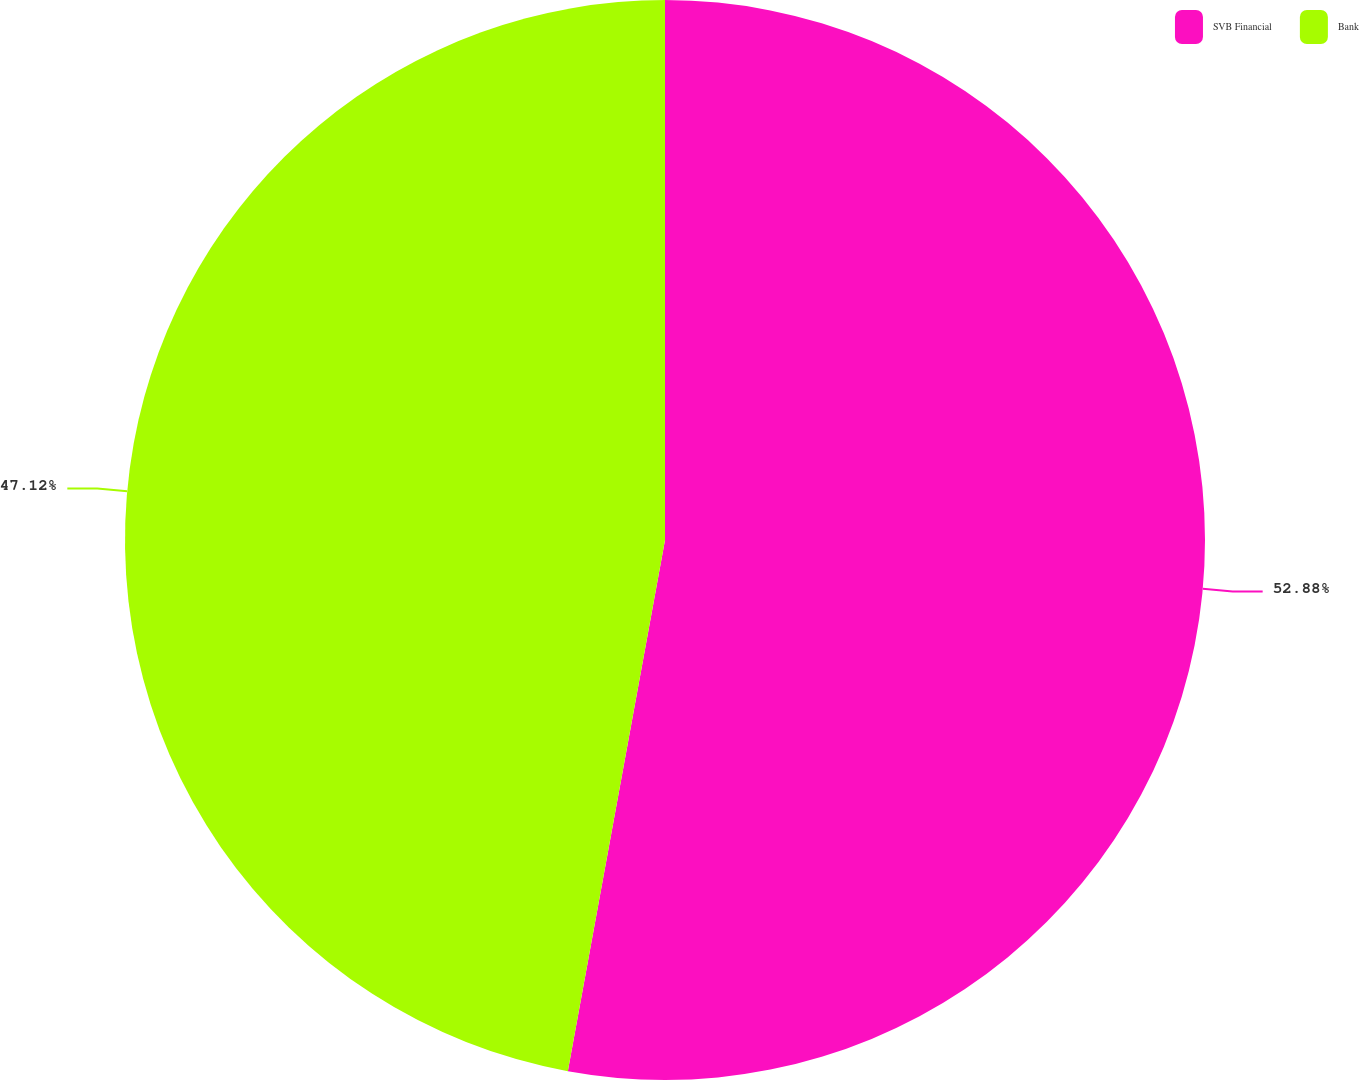<chart> <loc_0><loc_0><loc_500><loc_500><pie_chart><fcel>SVB Financial<fcel>Bank<nl><fcel>52.88%<fcel>47.12%<nl></chart> 